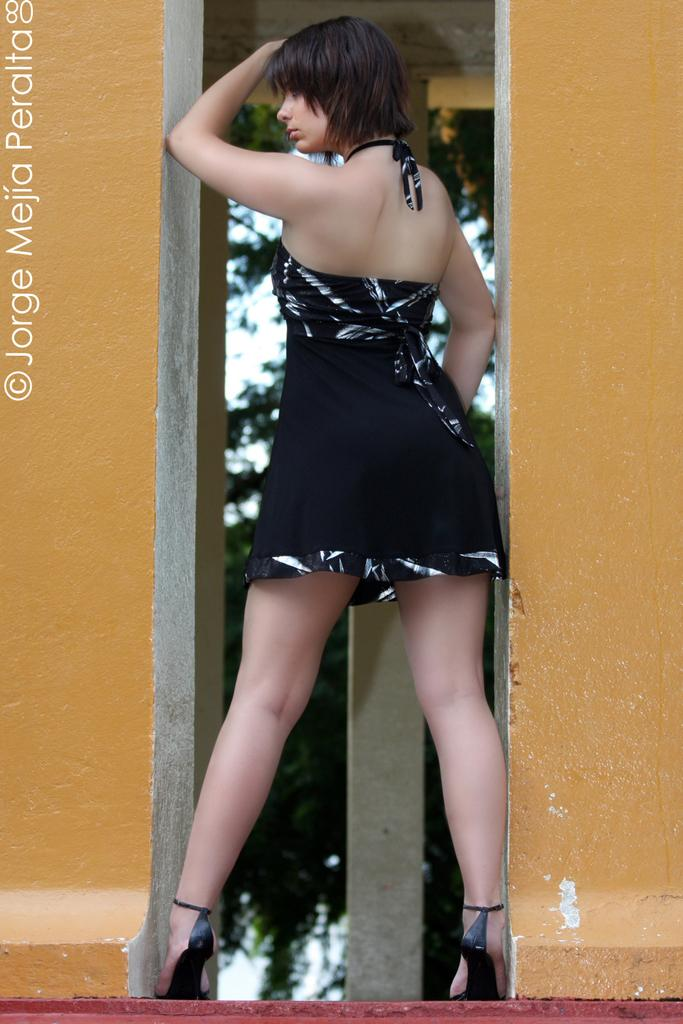Who is present in the image? There is a lady in the image. What architectural feature can be seen in the image? There is a pillar in the image. What surrounds the lady in the image? There are walls on both sides in the image. How would you describe the background of the image? The background is blurred. Where can text be found in the image? The text is on the left side of the image. What type of cushion is being adjusted by the lady in the image? There is no cushion present in the image, nor is the lady adjusting anything. 